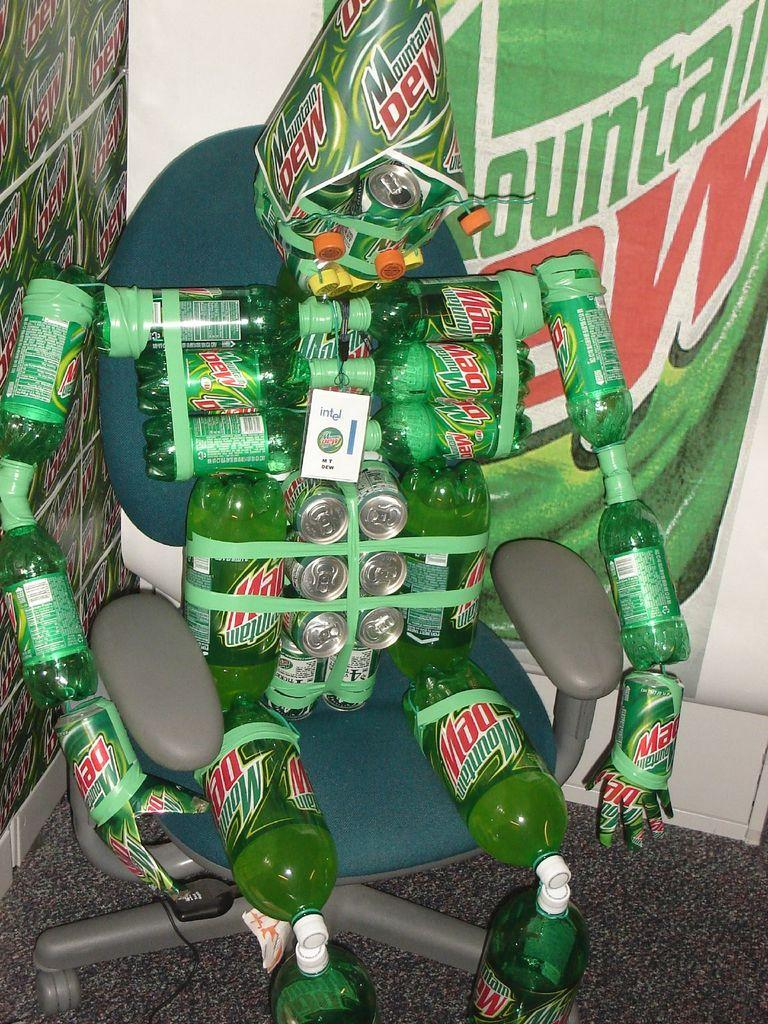Provide a one-sentence caption for the provided image. All the Mountain Dew bottles and cans have been taped together in the shape of a man and seated in an office chair. 